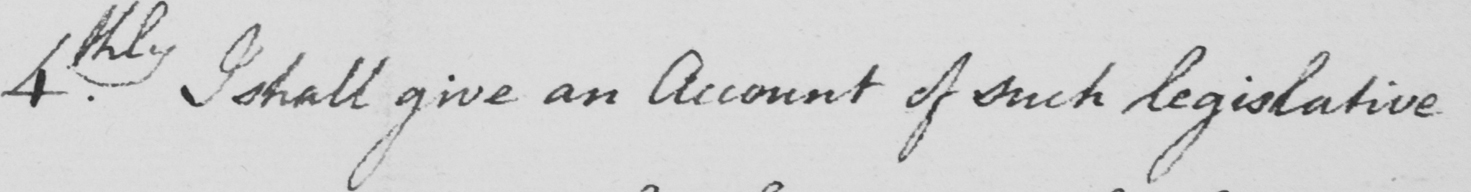What is written in this line of handwriting? 4thly . I shall give an Account of such legislative 